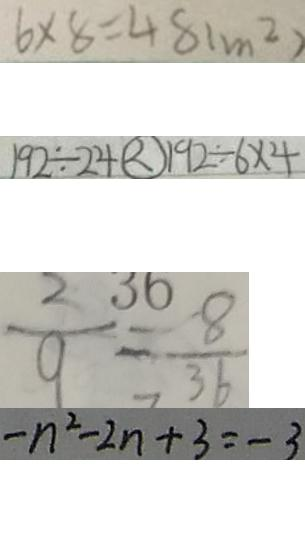<formula> <loc_0><loc_0><loc_500><loc_500>6 \times 8 = 4 8 ( m ^ { 2 } ) 
 1 9 2 \div 2 4 \textcircled { < } 1 9 2 \div 6 \times 4 
 \frac { 2 } { 9 } = \frac { 8 } { 3 6 } 
 - n ^ { 2 } - 2 n + 3 = - 3</formula> 